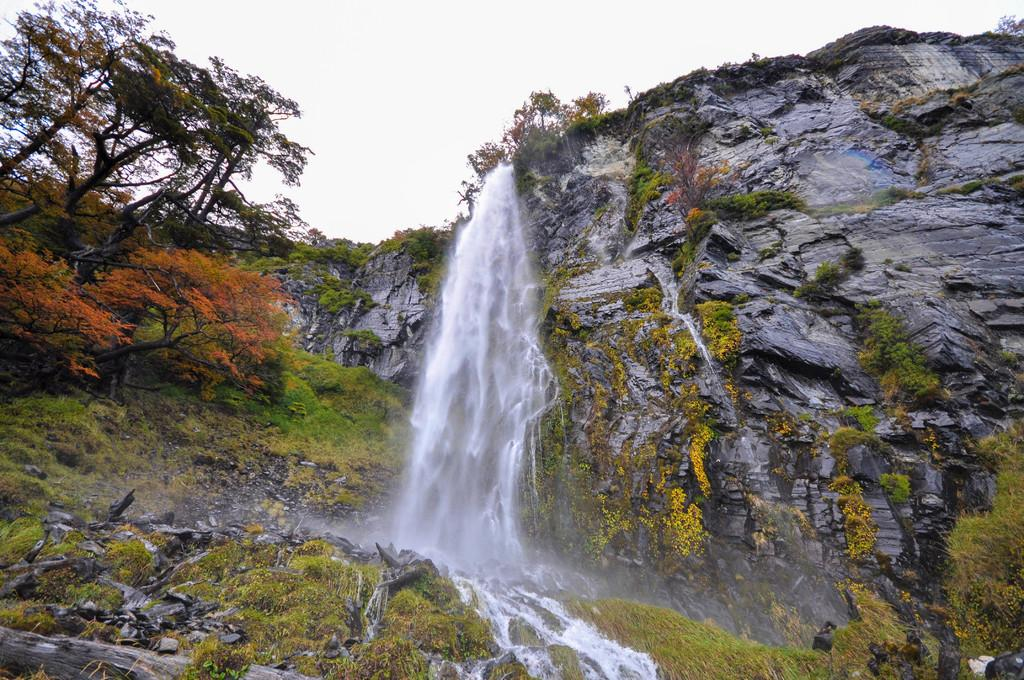What is the main feature of the image? There is a waterfall in the image. Where is the waterfall located? The waterfall is located on a mountain. How is the waterfall positioned in the image? The waterfall is in the center of the image. What can be seen in the top left corner of the image? There are trees in the top left corner of the image. What is visible at the top of the image? The sky is visible at the top of the image. What type of skin can be seen on the pan in the image? There is no pan or skin present in the image; it features a waterfall on a mountain. How many wings are visible on the waterfall in the image? Waterfalls do not have wings, so none are visible in the image. 